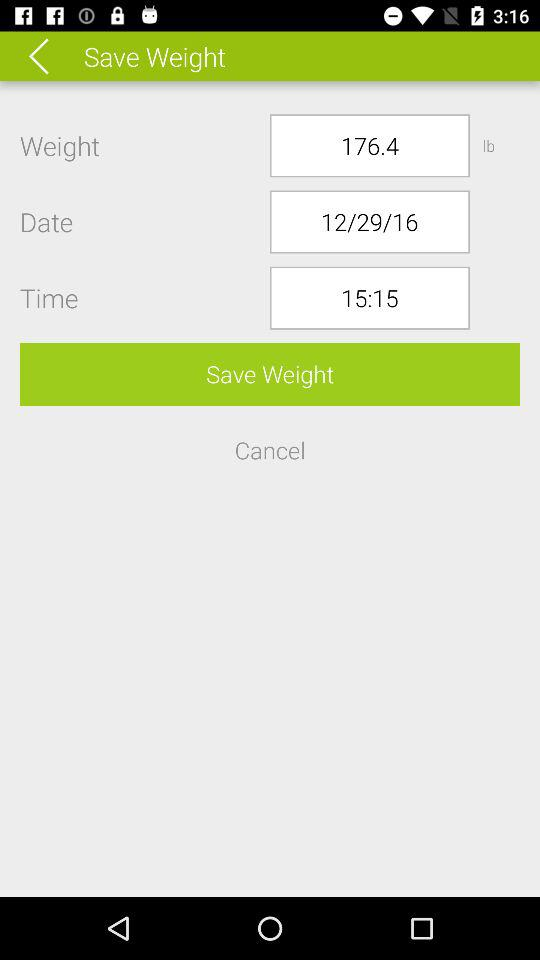What is the weight? The weight is 176.4 lb. 